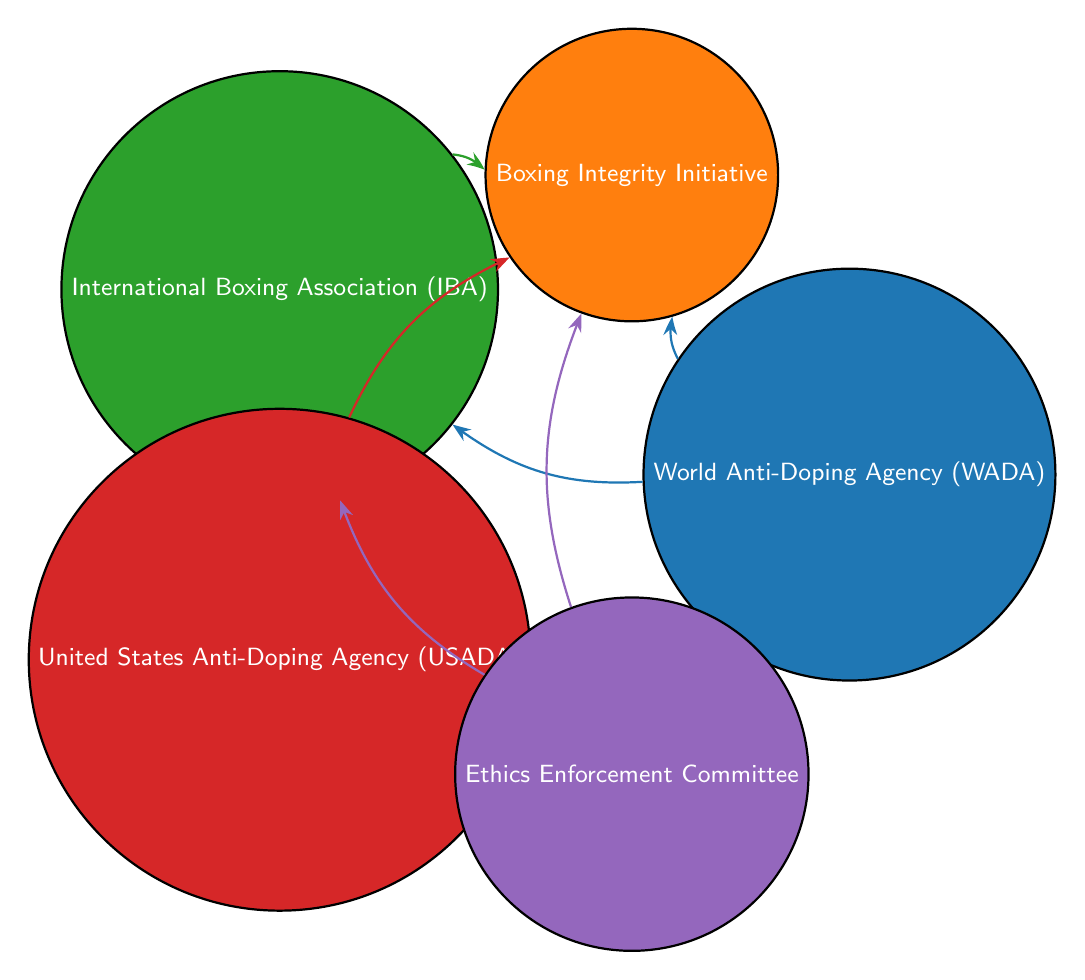What is the total number of nodes in the diagram? The diagram lists five entities involved in advocating for boxing integrity, which are considered as nodes. Counting them gives us a total of five nodes.
Answer: 5 Which organization is connected to the Boxing Integrity Initiative? The Boxing Integrity Initiative has three connections from the World Anti-Doping Agency, the International Boxing Association, and the United States Anti-Doping Agency. So, there are three organizations connected to it.
Answer: 3 How many links are directed towards the International Boxing Association? The International Boxing Association has three directed connections: one from the World Anti-Doping Agency, one from the Ethics Enforcement Committee, and one from the Boxing Integrity Initiative. Adding these connections gives us a total of three directed links.
Answer: 3 Which two organizations are connected to the Ethics Enforcement Committee? The Ethics Enforcement Committee has two outgoing connections: one to the International Boxing Association and one to the Boxing Integrity Initiative. Therefore, these two organizations are directly connected to it.
Answer: International Boxing Association, Boxing Integrity Initiative What is the relationship between WADA and IBA? The World Anti-Doping Agency has a direct connection to the International Boxing Association, indicating a partnership or support between these two organizations in promoting boxing integrity.
Answer: Connection Which organization has the most connections in the diagram? Among all the nodes, the Boxing Integrity Initiative is connected to three organizations: WADA, IBA, and USADA, making it the node with the most connections in the diagram.
Answer: Boxing Integrity Initiative Are there any organizations that link both WADA and the Boxing Integrity Initiative? Yes, the Boxing Integrity Initiative is linked to the World Anti-Doping Agency and also receives support from the International Boxing Association, indicating that both organizations are advocating for integrity together.
Answer: Yes How many edges are there between the different organizations? The diagram shows a total of six directed connections (or edges) among the organizations, illustrating their collaborative efforts in promoting boxing integrity.
Answer: 6 